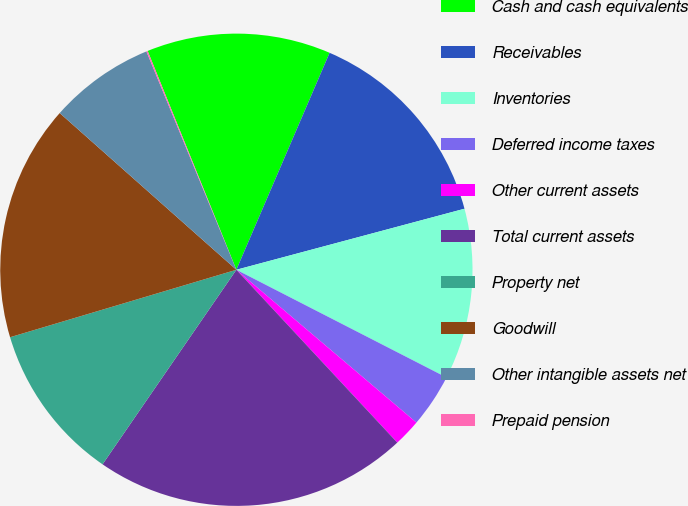Convert chart to OTSL. <chart><loc_0><loc_0><loc_500><loc_500><pie_chart><fcel>Cash and cash equivalents<fcel>Receivables<fcel>Inventories<fcel>Deferred income taxes<fcel>Other current assets<fcel>Total current assets<fcel>Property net<fcel>Goodwill<fcel>Other intangible assets net<fcel>Prepaid pension<nl><fcel>12.59%<fcel>14.38%<fcel>11.7%<fcel>3.66%<fcel>1.87%<fcel>21.52%<fcel>10.8%<fcel>16.16%<fcel>7.23%<fcel>0.09%<nl></chart> 